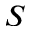Convert formula to latex. <formula><loc_0><loc_0><loc_500><loc_500>S</formula> 